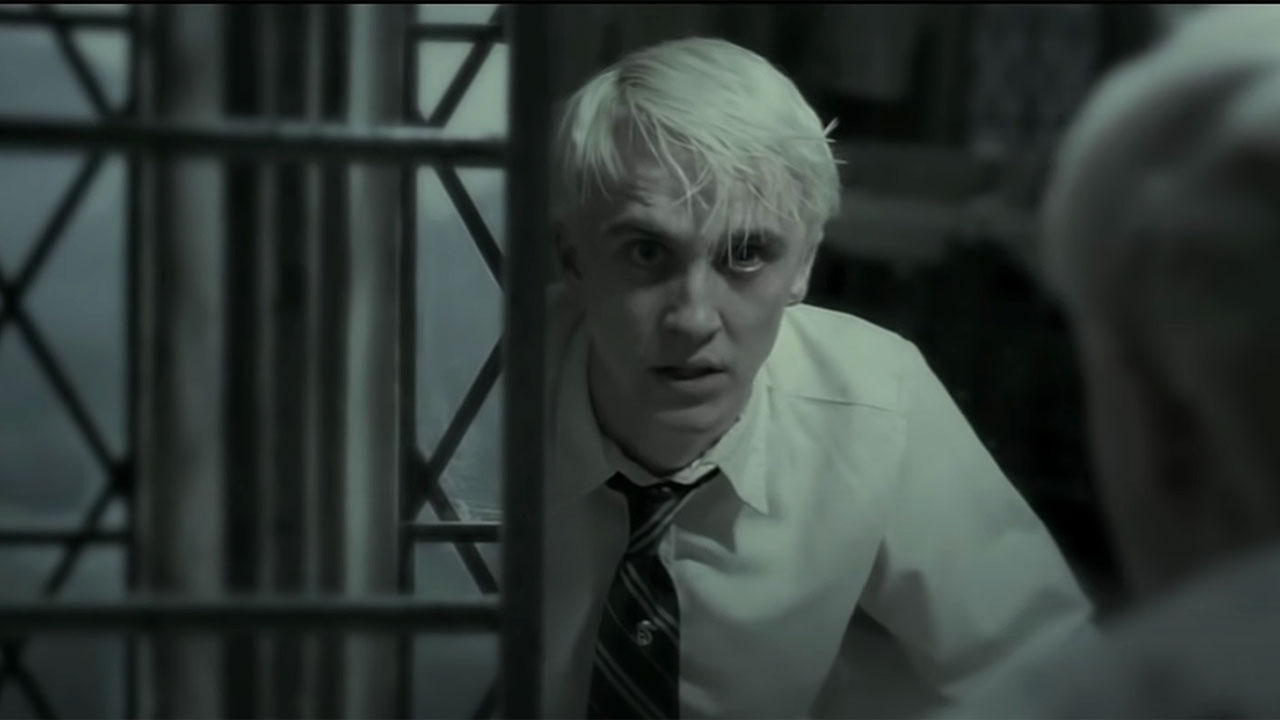What might Draco be thinking in this moment? In this intense moment, Draco might be consumed by thoughts of fear and uncertainty. He could be grappling with the enormity of the situation he's in, the impossibility of the task he's been given, and the potential consequences if he fails. Thoughts of his family, the pressure from Voldemort, and the rapidly shifting dynamics at Hogwarts might be whirling in his mind. He likely feels trapped, both literally and figuratively, caught in a situation where every decision could lead to dire outcomes. What if Draco has just discovered a hidden power within himself? Elaborate on that scenario. Imagine Draco, in the midst of all his fears and conflicts, discovers a hidden power within himself. The realization hits him like a bolt of lightning, evident from his shocked expression. This newfound power is unlike any magic he has learned; it is ancient, intuitive, and immensely powerful. It is a deeply buried legacy from a forgotten era, awakening within him during this extreme moment of stress. With this power, Draco suddenly sees visions of past and future events blending together. He sees his ancestors, the ancient wizards, bestowing upon him this gift to alter the course of history. As he grasps the magnitude and responsibility of this power, the metal bars in front of him start to dissolve, symbolizing breaking free from his fears and the constraints imposed by others. He stands ready to embrace this mysterious power and reshape his destiny, potentially altering the course of the wizarding world forever. 